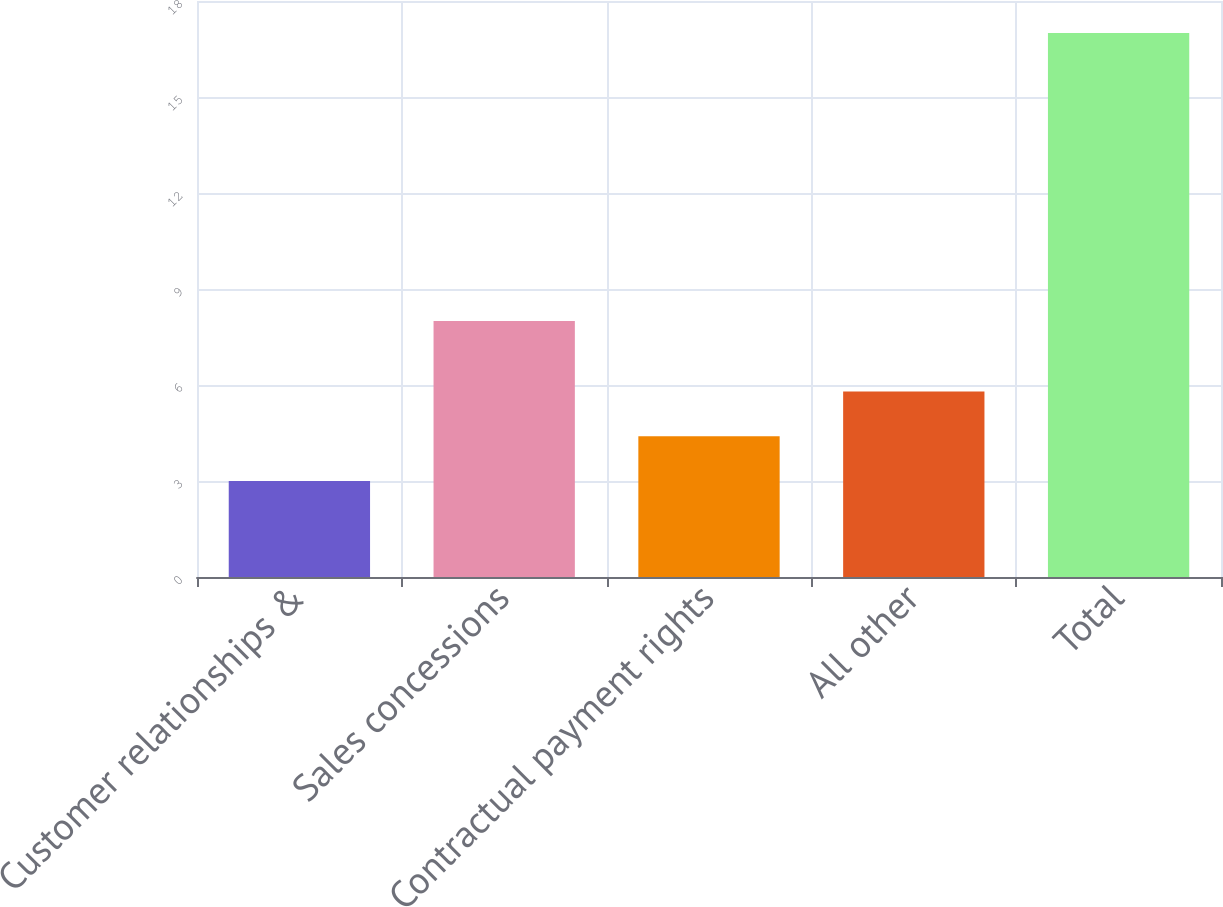<chart> <loc_0><loc_0><loc_500><loc_500><bar_chart><fcel>Customer relationships &<fcel>Sales concessions<fcel>Contractual payment rights<fcel>All other<fcel>Total<nl><fcel>3<fcel>8<fcel>4.4<fcel>5.8<fcel>17<nl></chart> 